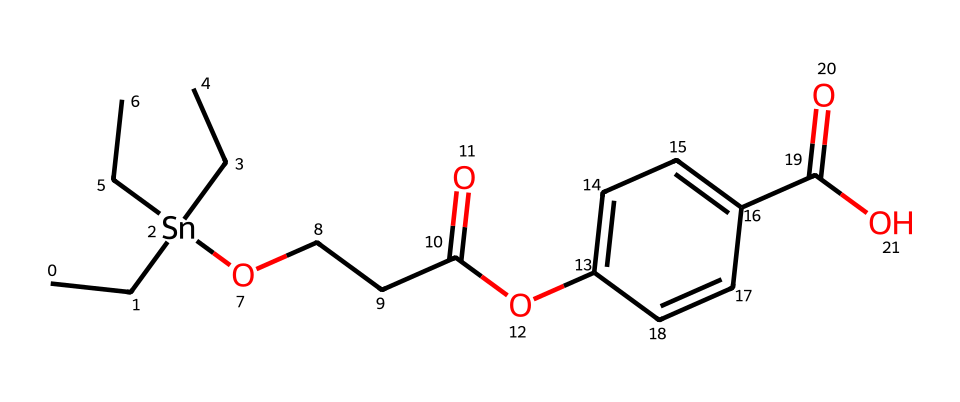What is the central atom in this organotin compound? The central atom in any organotin compound is typically tin, which is indicated by the Sn in the SMILES representation.
Answer: tin How many carbon atoms are present in the compound? By analyzing the SMILES notation, there are 11 carbon atoms represented by the 'C' symbols.
Answer: 11 What functional groups are present in this organotin compound? The compound contains an ester functional group (indicated by O=C and O- connections) and a carboxylic acid functional group (indicated by the –C(=O)OH).
Answer: ester, carboxylic acid What is the role of the tin atom in the context of antifouling properties? The tin atom acts as a biocide, preventing the growth of marine organisms on boat surfaces, which is essential for antifouling applications.
Answer: biocide How many oxygen atoms are present in the compound? The SMILES notation contains 4 oxygen atoms, shown by the 'O' in various parts of the structure.
Answer: 4 Which component of the structure increases water solubility? The presence of the ester (-O-) and carboxylic acid (-C(=O)OH) moieties enhances the hydrophilicity of the compound, contributing to its water solubility.
Answer: ester, carboxylic acid What type of bonding is primarily involved between tin and carbon in this organotin compound? The bonding is primarily covalent, as organotin compounds typically involve covalent bonds between tin and carbon atoms rather than ionic bonds.
Answer: covalent 